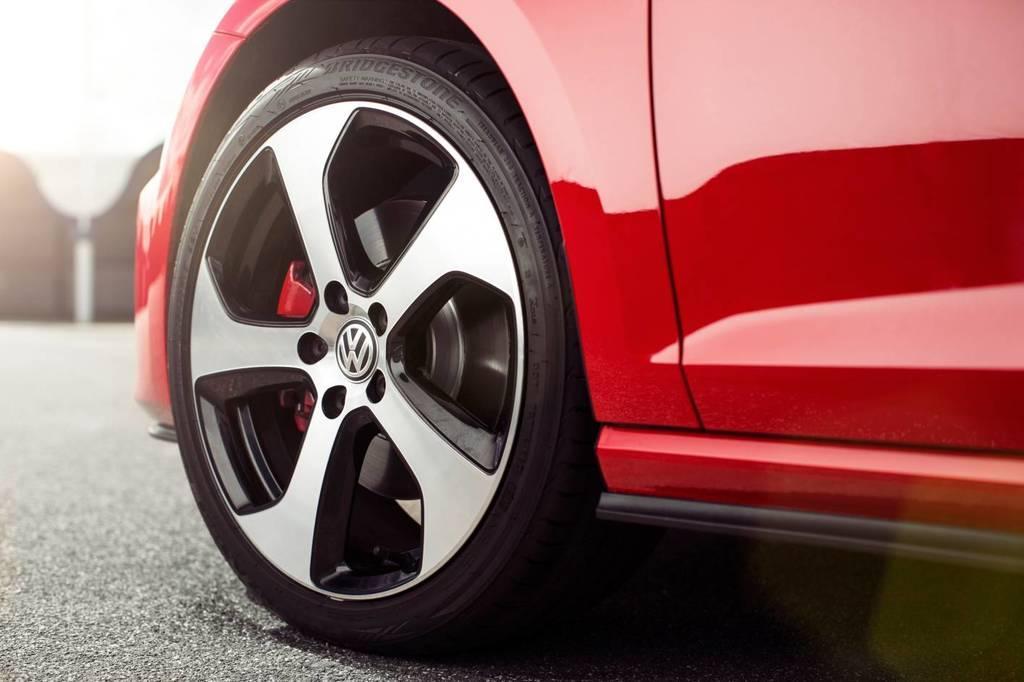Describe this image in one or two sentences. In this picture we can see the wheel of a vehicle on the road and in the background it is blurry. 